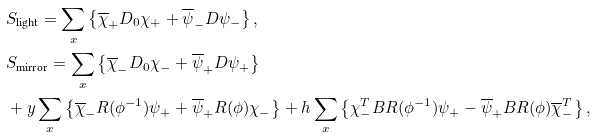<formula> <loc_0><loc_0><loc_500><loc_500>& S _ { \text {light} } = \sum _ { x } \left \{ \overline { \chi } _ { + } D _ { 0 } \chi _ { + } + \overline { \psi } _ { - } D \psi _ { - } \right \} , \\ & S _ { \text {mirror} } = \sum _ { x } \left \{ \overline { \chi } _ { - } D _ { 0 } \chi _ { - } + \overline { \psi } _ { + } D \psi _ { + } \right \} \\ & + y \sum _ { x } \left \{ \overline { \chi } _ { - } R ( \phi ^ { - 1 } ) \psi _ { + } + \overline { \psi } _ { + } R ( \phi ) \chi _ { - } \right \} + h \sum _ { x } \left \{ \chi _ { - } ^ { T } B R ( \phi ^ { - 1 } ) \psi _ { + } - \overline { \psi } _ { + } B R ( \phi ) \overline { \chi } _ { - } ^ { T } \right \} ,</formula> 